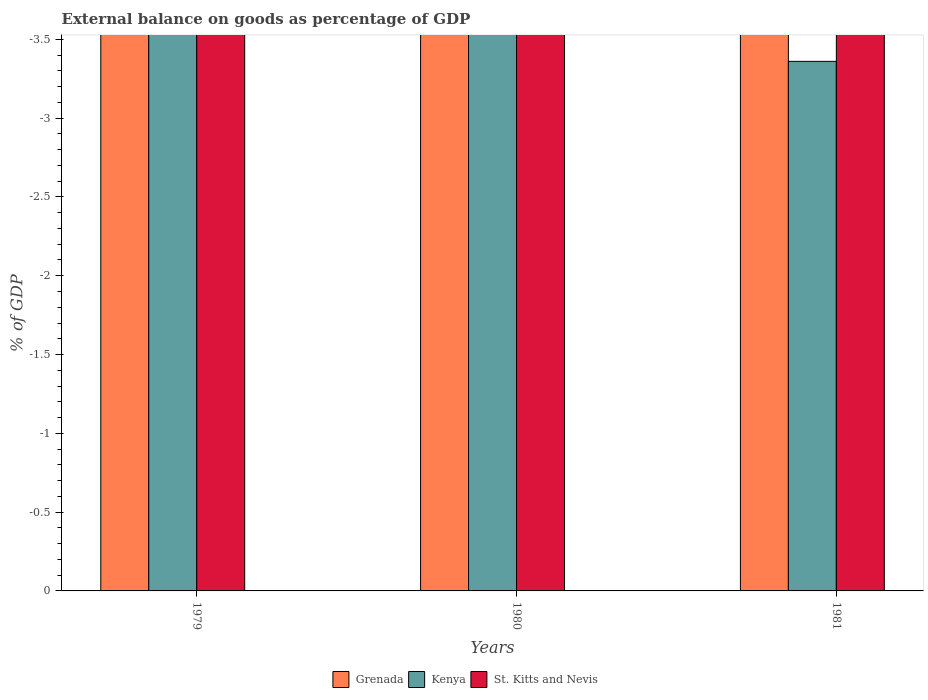Are the number of bars on each tick of the X-axis equal?
Make the answer very short. Yes. Across all years, what is the minimum external balance on goods as percentage of GDP in Grenada?
Offer a terse response. 0. What is the total external balance on goods as percentage of GDP in Grenada in the graph?
Offer a very short reply. 0. What is the difference between the external balance on goods as percentage of GDP in St. Kitts and Nevis in 1980 and the external balance on goods as percentage of GDP in Kenya in 1979?
Offer a very short reply. 0. What is the average external balance on goods as percentage of GDP in Grenada per year?
Provide a succinct answer. 0. In how many years, is the external balance on goods as percentage of GDP in Grenada greater than -3.1 %?
Offer a terse response. 0. Is it the case that in every year, the sum of the external balance on goods as percentage of GDP in St. Kitts and Nevis and external balance on goods as percentage of GDP in Grenada is greater than the external balance on goods as percentage of GDP in Kenya?
Make the answer very short. No. How many bars are there?
Provide a short and direct response. 0. How many years are there in the graph?
Give a very brief answer. 3. What is the difference between two consecutive major ticks on the Y-axis?
Your answer should be very brief. 0.5. Does the graph contain any zero values?
Offer a terse response. Yes. How many legend labels are there?
Make the answer very short. 3. What is the title of the graph?
Offer a terse response. External balance on goods as percentage of GDP. Does "Namibia" appear as one of the legend labels in the graph?
Give a very brief answer. No. What is the label or title of the Y-axis?
Your answer should be compact. % of GDP. What is the % of GDP in Kenya in 1979?
Offer a terse response. 0. What is the % of GDP in St. Kitts and Nevis in 1979?
Your response must be concise. 0. What is the % of GDP in Kenya in 1980?
Offer a very short reply. 0. What is the % of GDP in St. Kitts and Nevis in 1980?
Provide a succinct answer. 0. What is the % of GDP in Kenya in 1981?
Your answer should be very brief. 0. What is the % of GDP in St. Kitts and Nevis in 1981?
Make the answer very short. 0. What is the total % of GDP in Grenada in the graph?
Keep it short and to the point. 0. What is the total % of GDP in Kenya in the graph?
Keep it short and to the point. 0. What is the average % of GDP of St. Kitts and Nevis per year?
Ensure brevity in your answer.  0. 